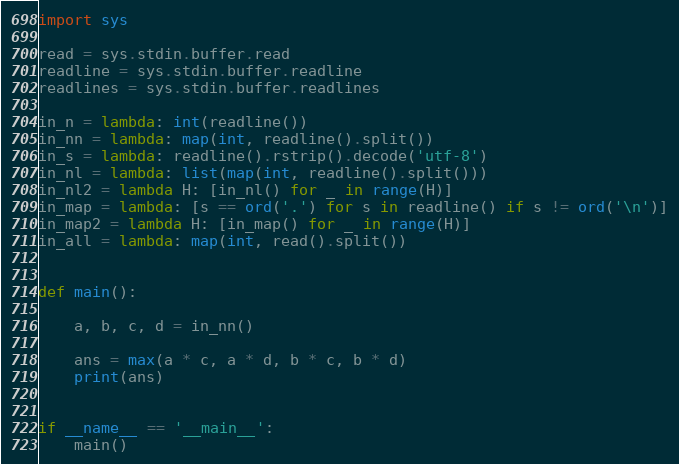Convert code to text. <code><loc_0><loc_0><loc_500><loc_500><_Python_>import sys

read = sys.stdin.buffer.read
readline = sys.stdin.buffer.readline
readlines = sys.stdin.buffer.readlines

in_n = lambda: int(readline())
in_nn = lambda: map(int, readline().split())
in_s = lambda: readline().rstrip().decode('utf-8')
in_nl = lambda: list(map(int, readline().split()))
in_nl2 = lambda H: [in_nl() for _ in range(H)]
in_map = lambda: [s == ord('.') for s in readline() if s != ord('\n')]
in_map2 = lambda H: [in_map() for _ in range(H)]
in_all = lambda: map(int, read().split())


def main():

    a, b, c, d = in_nn()

    ans = max(a * c, a * d, b * c, b * d)
    print(ans)


if __name__ == '__main__':
    main()
</code> 